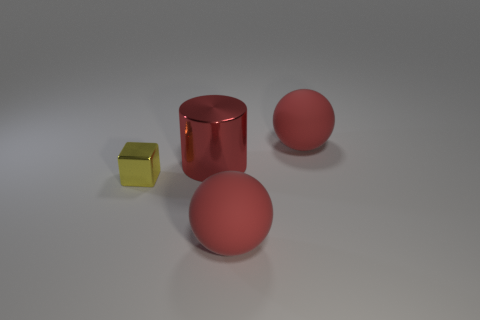Add 3 red shiny blocks. How many objects exist? 7 Subtract all blocks. How many objects are left? 3 Add 1 big objects. How many big objects exist? 4 Subtract 0 gray cylinders. How many objects are left? 4 Subtract all shiny objects. Subtract all red balls. How many objects are left? 0 Add 2 big cylinders. How many big cylinders are left? 3 